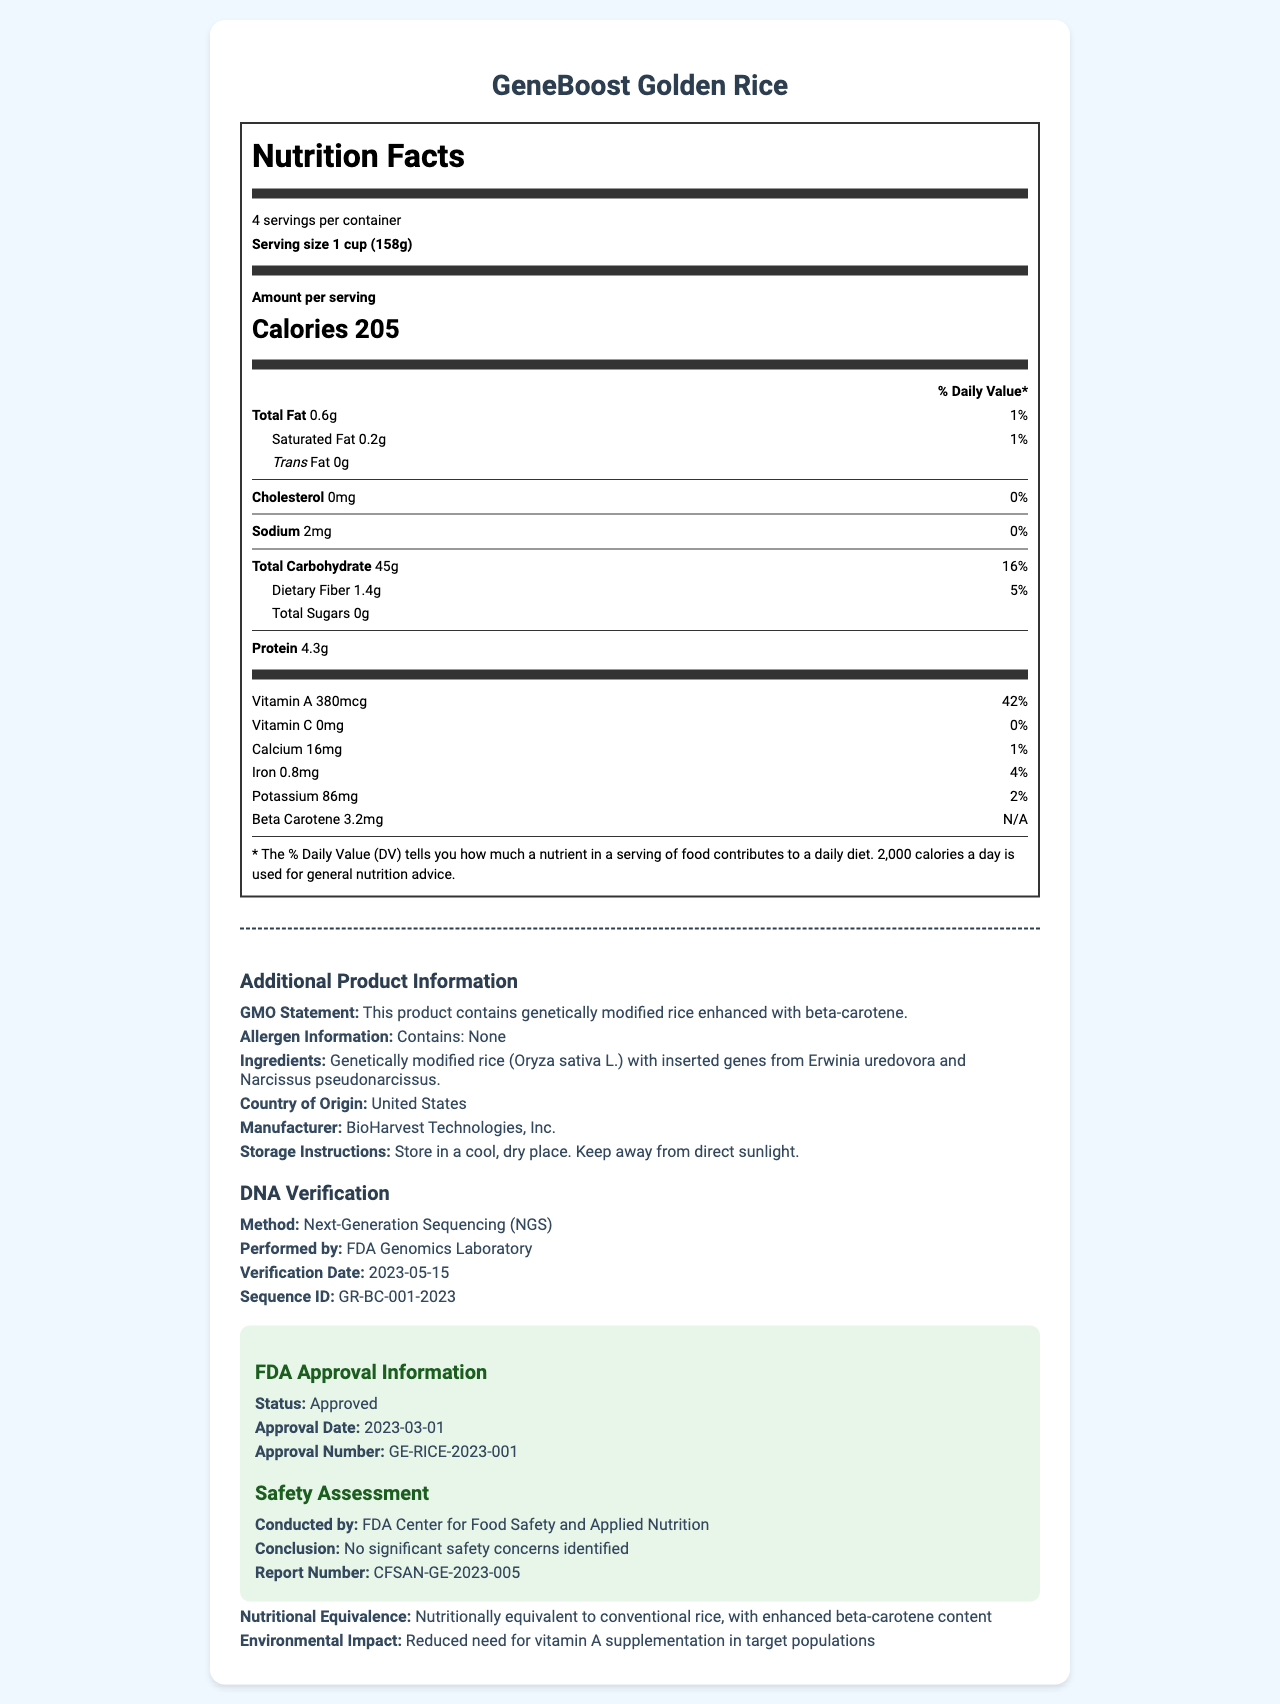what is the serving size? The serving size is clearly mentioned at the start of the nutrition label, right below the product name.
Answer: 1 cup (158g) what is the total fat content per serving? This information is listed under the "Amount per serving" section of the nutrition label.
Answer: 0.6g how many calories are in one serving? The calorie count is prominently displayed in large print in the "Amount per serving" section.
Answer: 205 is there any saturated fat in the product? Saturated fat content of 0.2g per serving is listed in the nutrition label.
Answer: Yes how much protein does one serving provide? The protein content is listed near the bottom of the "Amount per serving" section.
Answer: 4.3g how much vitamin A does one serving contain? This is listed under the vitamins information section of the nutrition label.
Answer: 380mcg what is the beta-carotene content per serving? This is showcased in the additional vitamins information on the nutrition label.
Answer: 3.2mg how much sodium is present in a serving? Sodium content is listed in the "Amount per serving" section of the nutrition label.
Answer: 2mg does the product contain any allergens? The allergen information clearly states "Contains: None."
Answer: No how is the DNA of this genetically modified rice verified? The DNA verification method is mentioned in the additional product information section.
Answer: Next-Generation Sequencing (NGS) of what phase is "FDA Approval Information" a part of? A. Manufacturing B. Distribution C. Pre-Market Approval D. Post-Market Surveillance The FDA approval information is a part of pre-market approval.
Answer: C which organization conducted the safety assessment? A. USDA B. FDA Center for Food Safety and Applied Nutrition C. WHO D. CDC The safety assessment was conducted by FDA Center for Food Safety and Applied Nutrition.
Answer: B is the product nutritionally equivalent to conventional rice? The document states that the product is nutritionally equivalent to conventional rice with enhanced beta-carotene content.
Answer: Yes is there any calcium in the product? The nutrient section states that each serving contains 16mg of calcium.
Answer: Yes how much is the % daily value of iron in a serving? The nutritional information includes the % daily value next to the amount of iron.
Answer: 4% describe the main idea of the document. The document summarizes the core nutritional properties of the GeneBoost Golden Rice and validates its safety, efficacy, and regulatory approval.
Answer: The document details the nutritional facts and additional information regarding GeneBoost Golden Rice, a genetically modified food product enhanced with beta-carotene. It outlines serving size, calories, macronutrient breakdown, and vitamin content. It also includes GMO statements, DNA verification methods, allergen information, FDA approval status, and safety assessment conclusions. who conducted the DNA verification for this product? The DNA verification section mentions that it was performed by the FDA Genomics Laboratory.
Answer: FDA Genomics Laboratory what are the storage instructions for the product? The storage instructions are provided in the additional product information section of the document.
Answer: Store in a cool, dry place. Keep away from direct sunlight. when was the FDA approval granted for this product? The FDA approval date is listed in the approval information section.
Answer: 2023-03-01 what genes were inserted into the genetically modified rice? The ingredients list includes information about the inserted genes.
Answer: Genes from Erwinia uredovora and Narcissus pseudonarcissus what is the cholesterol content per serving? The cholesterol content is mentioned in the "Amount per serving" section.
Answer: 0mg which technology was used for the DNA verification of GeneBoost Golden Rice? The verification method mentioned is Next-Generation Sequencing (NGS), but this question could intend to ask for more technical specifics that aren't covered in the document.
Answer: Can’t be determined from the document what role does bioharvest technologies inc. play in this product? The "Manufacturer" section in the additional information states that BioHarvest Technologies, Inc. is the manufacturer.
Answer: Manufacturer 